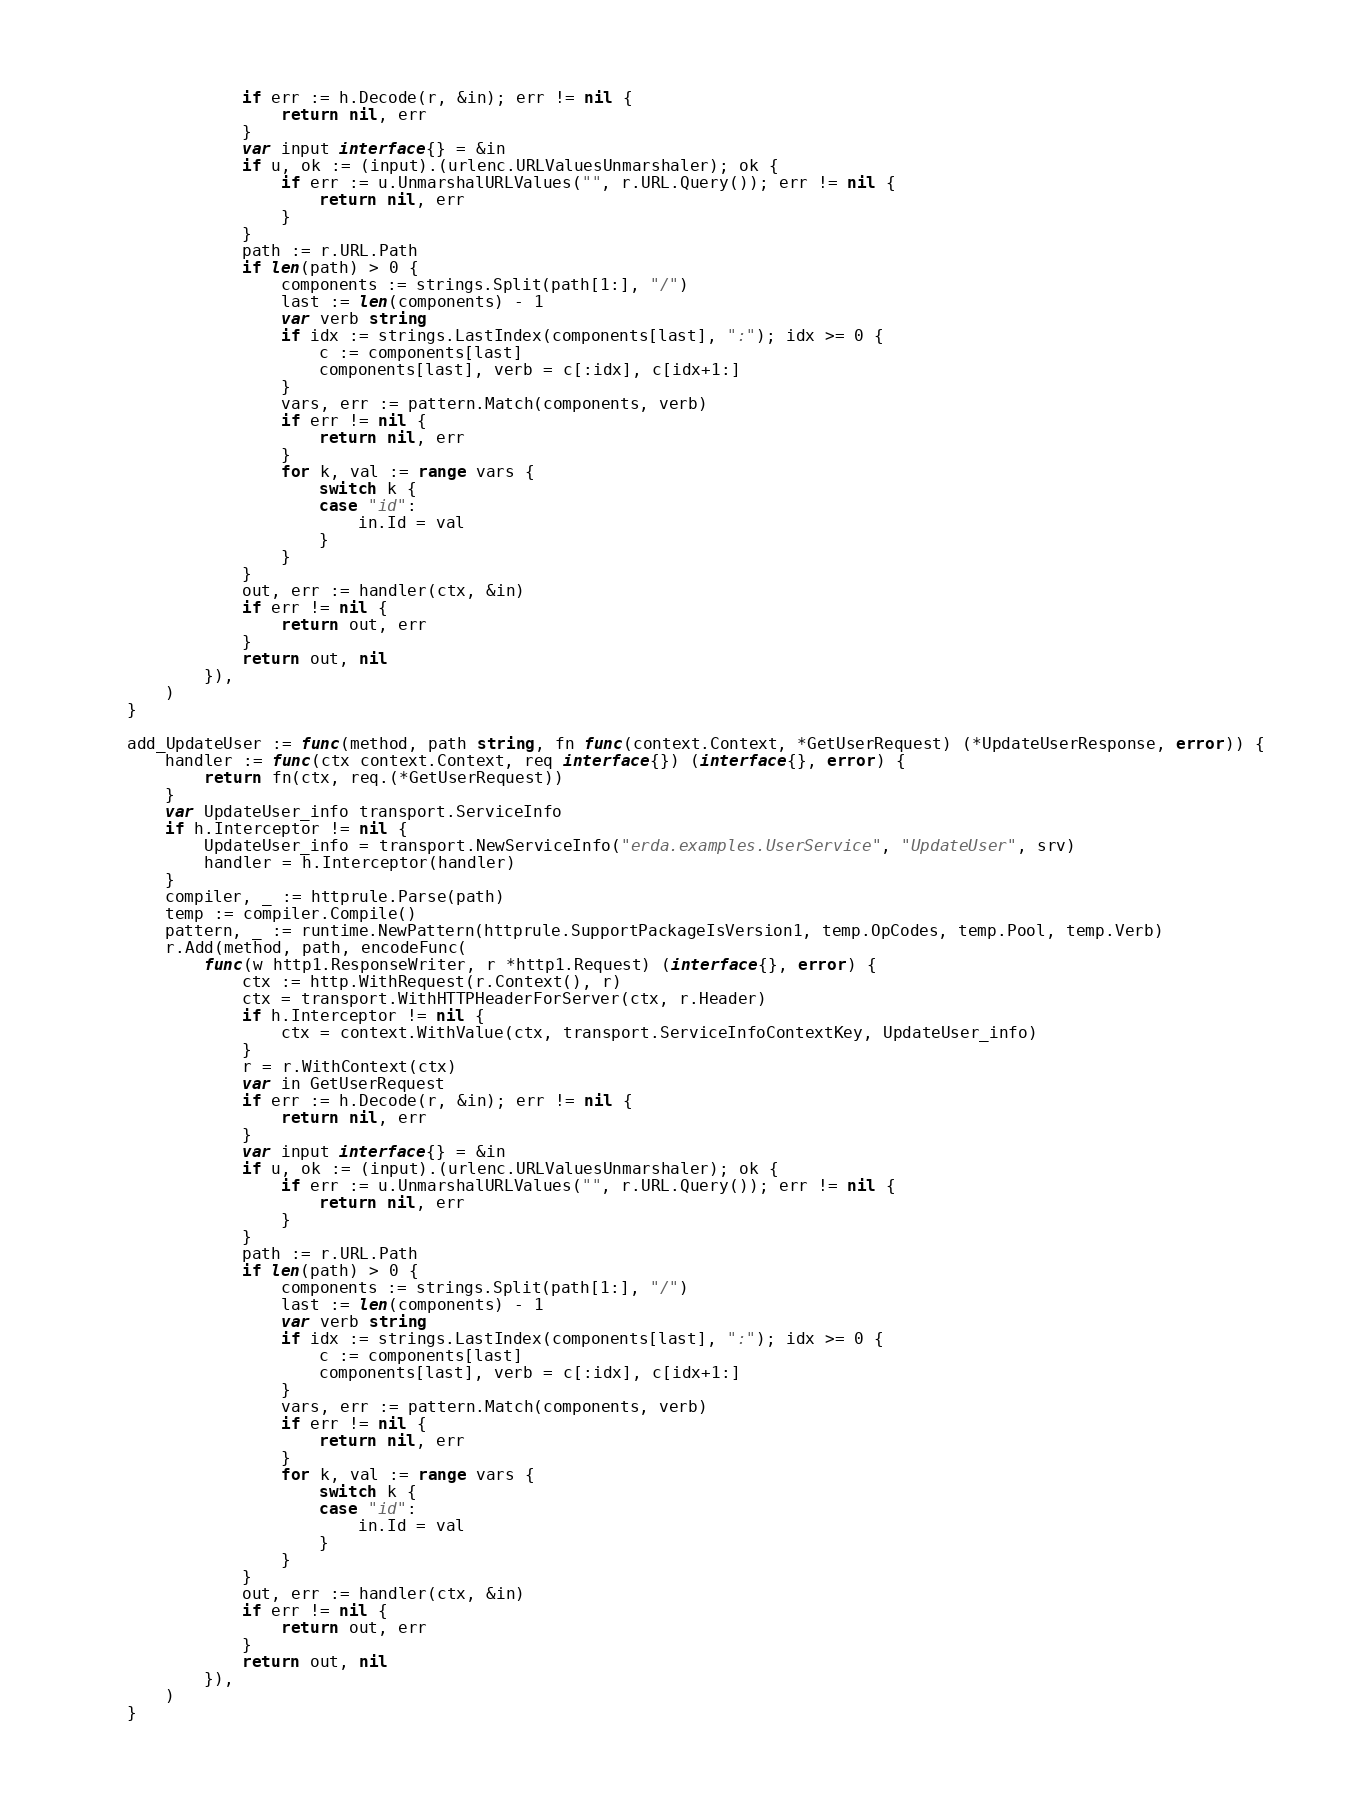Convert code to text. <code><loc_0><loc_0><loc_500><loc_500><_Go_>				if err := h.Decode(r, &in); err != nil {
					return nil, err
				}
				var input interface{} = &in
				if u, ok := (input).(urlenc.URLValuesUnmarshaler); ok {
					if err := u.UnmarshalURLValues("", r.URL.Query()); err != nil {
						return nil, err
					}
				}
				path := r.URL.Path
				if len(path) > 0 {
					components := strings.Split(path[1:], "/")
					last := len(components) - 1
					var verb string
					if idx := strings.LastIndex(components[last], ":"); idx >= 0 {
						c := components[last]
						components[last], verb = c[:idx], c[idx+1:]
					}
					vars, err := pattern.Match(components, verb)
					if err != nil {
						return nil, err
					}
					for k, val := range vars {
						switch k {
						case "id":
							in.Id = val
						}
					}
				}
				out, err := handler(ctx, &in)
				if err != nil {
					return out, err
				}
				return out, nil
			}),
		)
	}

	add_UpdateUser := func(method, path string, fn func(context.Context, *GetUserRequest) (*UpdateUserResponse, error)) {
		handler := func(ctx context.Context, req interface{}) (interface{}, error) {
			return fn(ctx, req.(*GetUserRequest))
		}
		var UpdateUser_info transport.ServiceInfo
		if h.Interceptor != nil {
			UpdateUser_info = transport.NewServiceInfo("erda.examples.UserService", "UpdateUser", srv)
			handler = h.Interceptor(handler)
		}
		compiler, _ := httprule.Parse(path)
		temp := compiler.Compile()
		pattern, _ := runtime.NewPattern(httprule.SupportPackageIsVersion1, temp.OpCodes, temp.Pool, temp.Verb)
		r.Add(method, path, encodeFunc(
			func(w http1.ResponseWriter, r *http1.Request) (interface{}, error) {
				ctx := http.WithRequest(r.Context(), r)
				ctx = transport.WithHTTPHeaderForServer(ctx, r.Header)
				if h.Interceptor != nil {
					ctx = context.WithValue(ctx, transport.ServiceInfoContextKey, UpdateUser_info)
				}
				r = r.WithContext(ctx)
				var in GetUserRequest
				if err := h.Decode(r, &in); err != nil {
					return nil, err
				}
				var input interface{} = &in
				if u, ok := (input).(urlenc.URLValuesUnmarshaler); ok {
					if err := u.UnmarshalURLValues("", r.URL.Query()); err != nil {
						return nil, err
					}
				}
				path := r.URL.Path
				if len(path) > 0 {
					components := strings.Split(path[1:], "/")
					last := len(components) - 1
					var verb string
					if idx := strings.LastIndex(components[last], ":"); idx >= 0 {
						c := components[last]
						components[last], verb = c[:idx], c[idx+1:]
					}
					vars, err := pattern.Match(components, verb)
					if err != nil {
						return nil, err
					}
					for k, val := range vars {
						switch k {
						case "id":
							in.Id = val
						}
					}
				}
				out, err := handler(ctx, &in)
				if err != nil {
					return out, err
				}
				return out, nil
			}),
		)
	}
</code> 